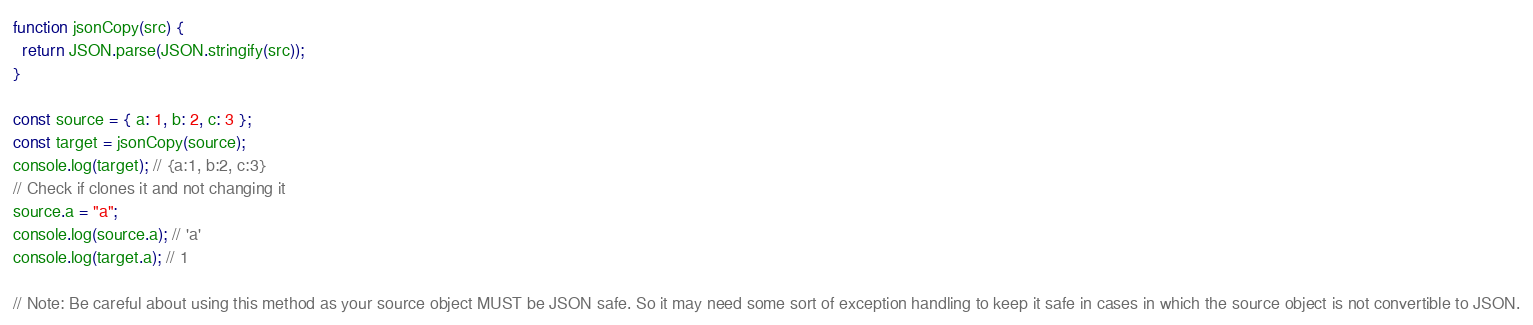<code> <loc_0><loc_0><loc_500><loc_500><_JavaScript_>
function jsonCopy(src) {
  return JSON.parse(JSON.stringify(src));
}

const source = { a: 1, b: 2, c: 3 };
const target = jsonCopy(source);
console.log(target); // {a:1, b:2, c:3}
// Check if clones it and not changing it
source.a = "a";
console.log(source.a); // 'a'
console.log(target.a); // 1

// Note: Be careful about using this method as your source object MUST be JSON safe. So it may need some sort of exception handling to keep it safe in cases in which the source object is not convertible to JSON.
</code> 